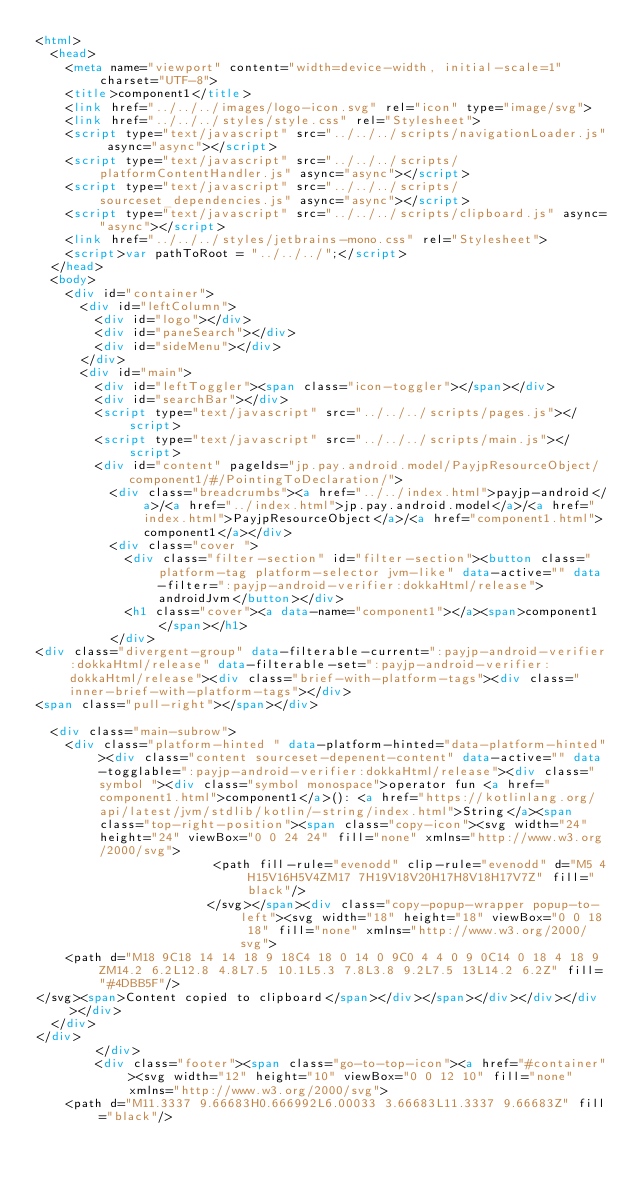<code> <loc_0><loc_0><loc_500><loc_500><_HTML_><html>
  <head>
    <meta name="viewport" content="width=device-width, initial-scale=1" charset="UTF-8">
    <title>component1</title>
    <link href="../../../images/logo-icon.svg" rel="icon" type="image/svg">
    <link href="../../../styles/style.css" rel="Stylesheet">
    <script type="text/javascript" src="../../../scripts/navigationLoader.js" async="async"></script>
    <script type="text/javascript" src="../../../scripts/platformContentHandler.js" async="async"></script>
    <script type="text/javascript" src="../../../scripts/sourceset_dependencies.js" async="async"></script>
    <script type="text/javascript" src="../../../scripts/clipboard.js" async="async"></script>
    <link href="../../../styles/jetbrains-mono.css" rel="Stylesheet">
    <script>var pathToRoot = "../../../";</script>
  </head>
  <body>
    <div id="container">
      <div id="leftColumn">
        <div id="logo"></div>
        <div id="paneSearch"></div>
        <div id="sideMenu"></div>
      </div>
      <div id="main">
        <div id="leftToggler"><span class="icon-toggler"></span></div>
        <div id="searchBar"></div>
        <script type="text/javascript" src="../../../scripts/pages.js"></script>
        <script type="text/javascript" src="../../../scripts/main.js"></script>
        <div id="content" pageIds="jp.pay.android.model/PayjpResourceObject/component1/#/PointingToDeclaration/">
          <div class="breadcrumbs"><a href="../../index.html">payjp-android</a>/<a href="../index.html">jp.pay.android.model</a>/<a href="index.html">PayjpResourceObject</a>/<a href="component1.html">component1</a></div>
          <div class="cover ">
            <div class="filter-section" id="filter-section"><button class="platform-tag platform-selector jvm-like" data-active="" data-filter=":payjp-android-verifier:dokkaHtml/release">androidJvm</button></div>
            <h1 class="cover"><a data-name="component1"></a><span>component1</span></h1>
          </div>
<div class="divergent-group" data-filterable-current=":payjp-android-verifier:dokkaHtml/release" data-filterable-set=":payjp-android-verifier:dokkaHtml/release"><div class="brief-with-platform-tags"><div class="inner-brief-with-platform-tags"></div>
<span class="pull-right"></span></div>

  <div class="main-subrow">
    <div class="platform-hinted " data-platform-hinted="data-platform-hinted"><div class="content sourceset-depenent-content" data-active="" data-togglable=":payjp-android-verifier:dokkaHtml/release"><div class="symbol "><div class="symbol monospace">operator fun <a href="component1.html">component1</a>(): <a href="https://kotlinlang.org/api/latest/jvm/stdlib/kotlin/-string/index.html">String</a><span class="top-right-position"><span class="copy-icon"><svg width="24" height="24" viewBox="0 0 24 24" fill="none" xmlns="http://www.w3.org/2000/svg">
                        <path fill-rule="evenodd" clip-rule="evenodd" d="M5 4H15V16H5V4ZM17 7H19V18V20H17H8V18H17V7Z" fill="black"/>
                       </svg></span><div class="copy-popup-wrapper popup-to-left"><svg width="18" height="18" viewBox="0 0 18 18" fill="none" xmlns="http://www.w3.org/2000/svg">
    <path d="M18 9C18 14 14 18 9 18C4 18 0 14 0 9C0 4 4 0 9 0C14 0 18 4 18 9ZM14.2 6.2L12.8 4.8L7.5 10.1L5.3 7.8L3.8 9.2L7.5 13L14.2 6.2Z" fill="#4DBB5F"/>
</svg><span>Content copied to clipboard</span></div></span></div></div></div></div>
  </div>
</div>
        </div>
        <div class="footer"><span class="go-to-top-icon"><a href="#container"><svg width="12" height="10" viewBox="0 0 12 10" fill="none" xmlns="http://www.w3.org/2000/svg">
    <path d="M11.3337 9.66683H0.666992L6.00033 3.66683L11.3337 9.66683Z" fill="black"/></code> 